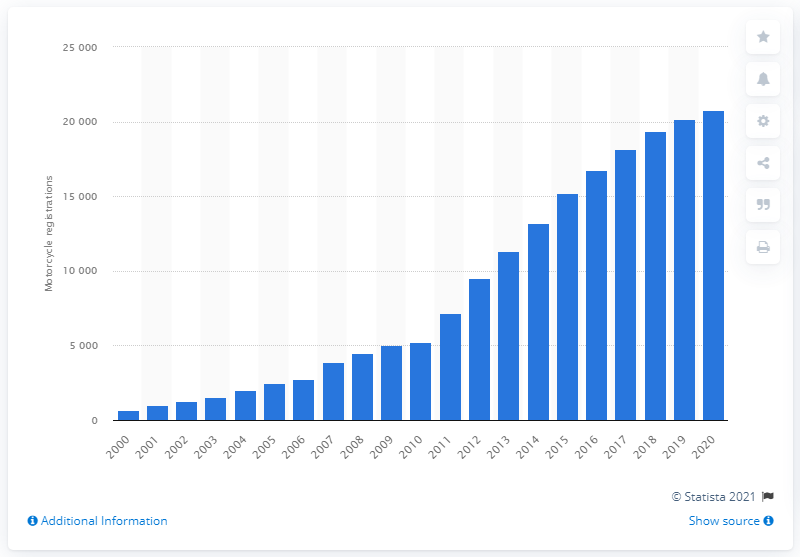Draw attention to some important aspects in this diagram. The number of registered motorcycles in Great Britain in 2000 was 689. 